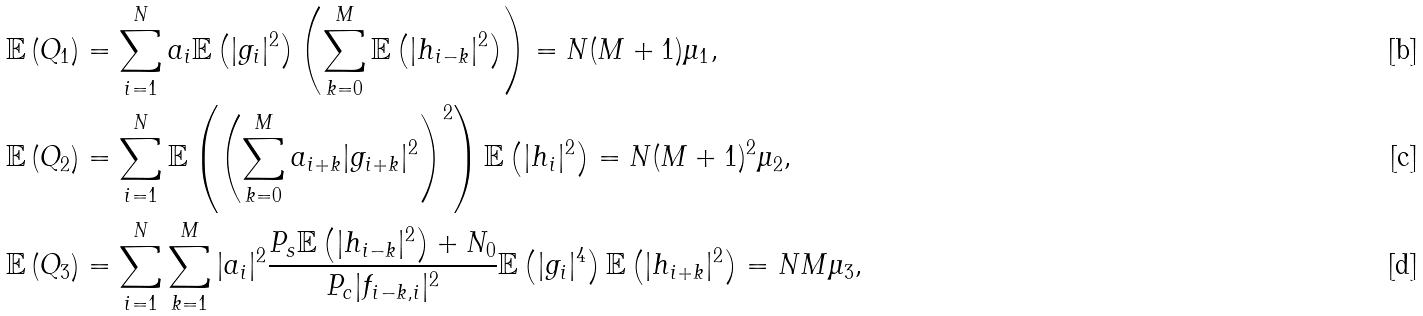<formula> <loc_0><loc_0><loc_500><loc_500>\mathbb { E } \left ( Q _ { 1 } \right ) & = \sum _ { i = 1 } ^ { N } a _ { i } \mathbb { E } \left ( | g _ { i } | ^ { 2 } \right ) \left ( \sum _ { k = 0 } ^ { M } \mathbb { E } \left ( | h _ { i - k } | ^ { 2 } \right ) \right ) = N ( M + 1 ) \mu _ { 1 } , \\ \mathbb { E } \left ( Q _ { 2 } \right ) & = \sum _ { i = 1 } ^ { N } \mathbb { E } \left ( \left ( \sum _ { k = 0 } ^ { M } a _ { i + k } | g _ { i + k } | ^ { 2 } \right ) ^ { 2 } \right ) \mathbb { E } \left ( | h _ { i } | ^ { 2 } \right ) = N ( M + 1 ) ^ { 2 } \mu _ { 2 } , \\ \mathbb { E } \left ( Q _ { 3 } \right ) & = \sum _ { i = 1 } ^ { N } \sum _ { k = 1 } ^ { M } | a _ { i } | ^ { 2 } \frac { P _ { s } \mathbb { E } \left ( | h _ { i - k } | ^ { 2 } \right ) + N _ { 0 } } { P _ { c } | f _ { i - k , i } | ^ { 2 } } \mathbb { E } \left ( | g _ { i } | ^ { 4 } \right ) \mathbb { E } \left ( | h _ { i + k } | ^ { 2 } \right ) = N M \mu _ { 3 } ,</formula> 